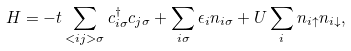<formula> <loc_0><loc_0><loc_500><loc_500>H = - t \sum _ { < { i j } > \sigma } c _ { { i } \sigma } ^ { \dagger } c _ { { j } \sigma } + \sum _ { { i } \sigma } \epsilon _ { i } n _ { { i } \sigma } + U \sum _ { i } n _ { { i } \uparrow } n _ { { i } \downarrow } ,</formula> 